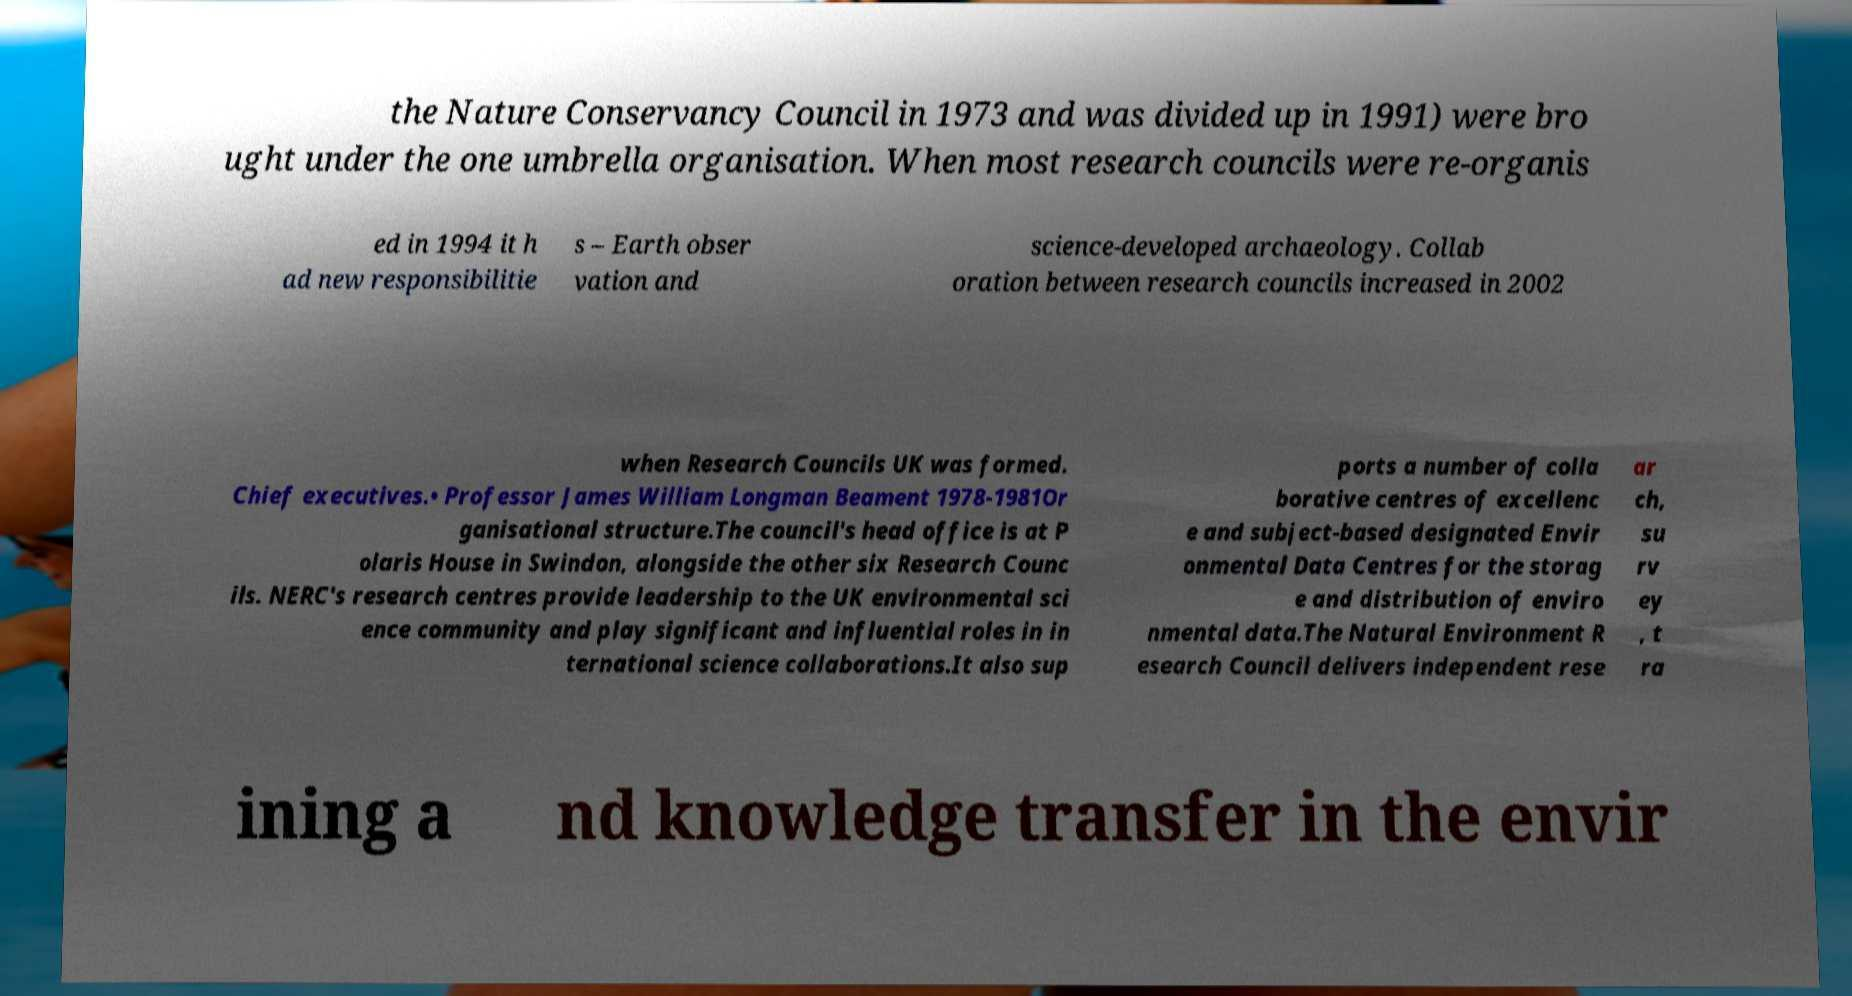For documentation purposes, I need the text within this image transcribed. Could you provide that? the Nature Conservancy Council in 1973 and was divided up in 1991) were bro ught under the one umbrella organisation. When most research councils were re-organis ed in 1994 it h ad new responsibilitie s – Earth obser vation and science-developed archaeology. Collab oration between research councils increased in 2002 when Research Councils UK was formed. Chief executives.• Professor James William Longman Beament 1978-1981Or ganisational structure.The council's head office is at P olaris House in Swindon, alongside the other six Research Counc ils. NERC's research centres provide leadership to the UK environmental sci ence community and play significant and influential roles in in ternational science collaborations.It also sup ports a number of colla borative centres of excellenc e and subject-based designated Envir onmental Data Centres for the storag e and distribution of enviro nmental data.The Natural Environment R esearch Council delivers independent rese ar ch, su rv ey , t ra ining a nd knowledge transfer in the envir 